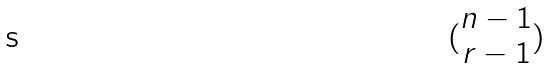<formula> <loc_0><loc_0><loc_500><loc_500>( \begin{matrix} n - 1 \\ r - 1 \end{matrix} )</formula> 